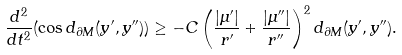<formula> <loc_0><loc_0><loc_500><loc_500>\frac { d ^ { 2 } } { d t ^ { 2 } } ( \cos d _ { \partial M } ( y ^ { \prime } , y ^ { \prime \prime } ) ) \geq - C \left ( \frac { | \mu ^ { \prime } | } { r ^ { \prime } } + \frac { | \mu ^ { \prime \prime } | } { r ^ { \prime \prime } } \right ) ^ { 2 } d _ { \partial M } ( y ^ { \prime } , y ^ { \prime \prime } ) .</formula> 